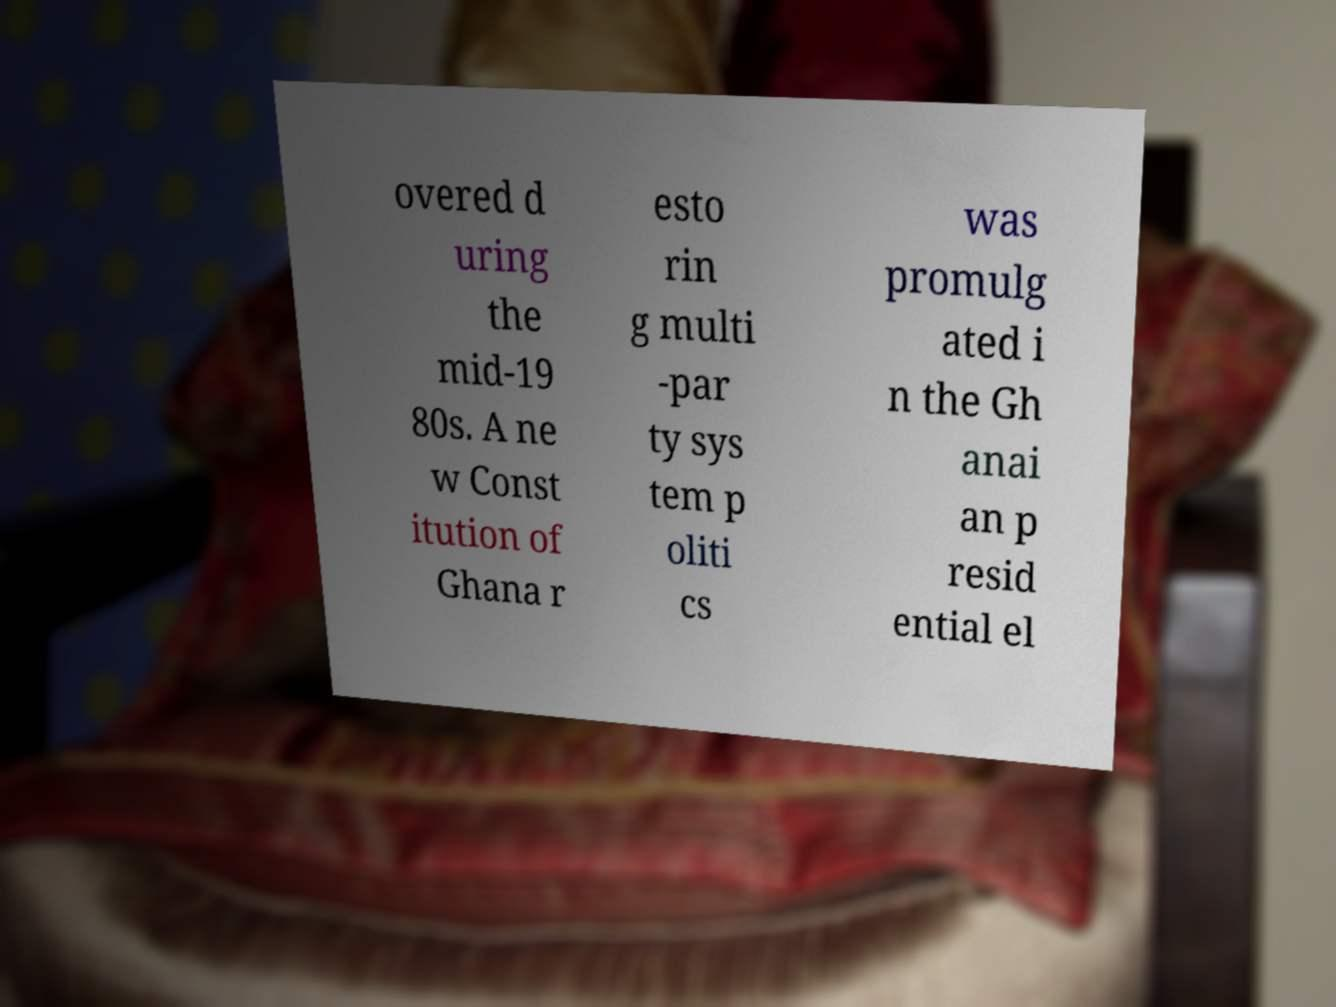Could you extract and type out the text from this image? overed d uring the mid-19 80s. A ne w Const itution of Ghana r esto rin g multi -par ty sys tem p oliti cs was promulg ated i n the Gh anai an p resid ential el 